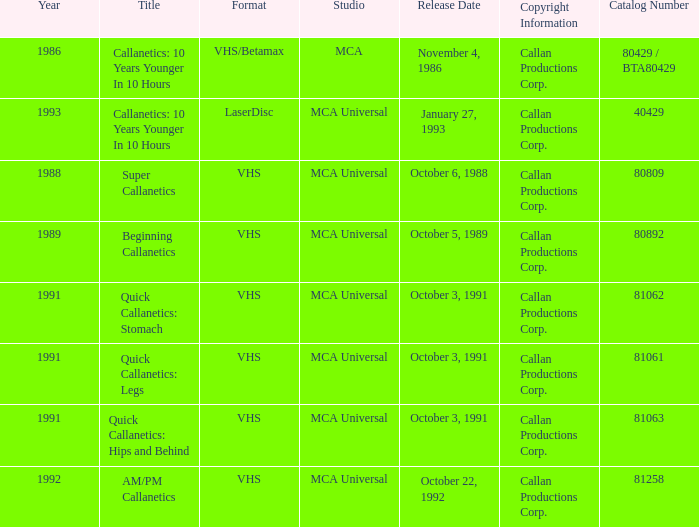Name the studio for catalog number 81063 MCA Universal. 